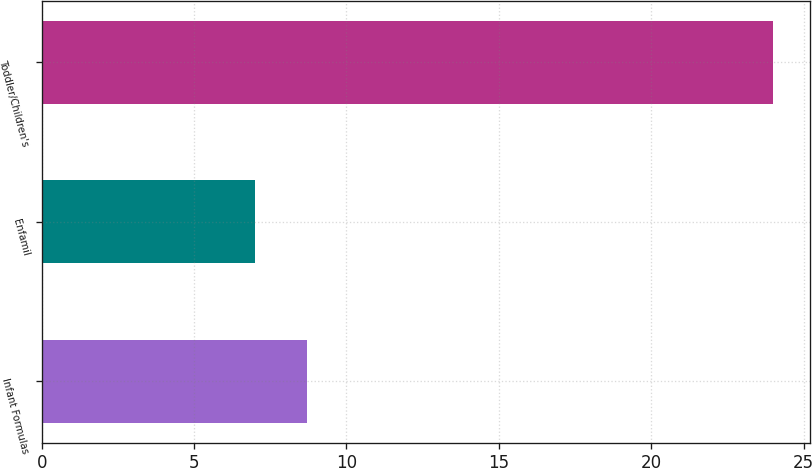<chart> <loc_0><loc_0><loc_500><loc_500><bar_chart><fcel>Infant Formulas<fcel>Enfamil<fcel>Toddler/Children's<nl><fcel>8.7<fcel>7<fcel>24<nl></chart> 